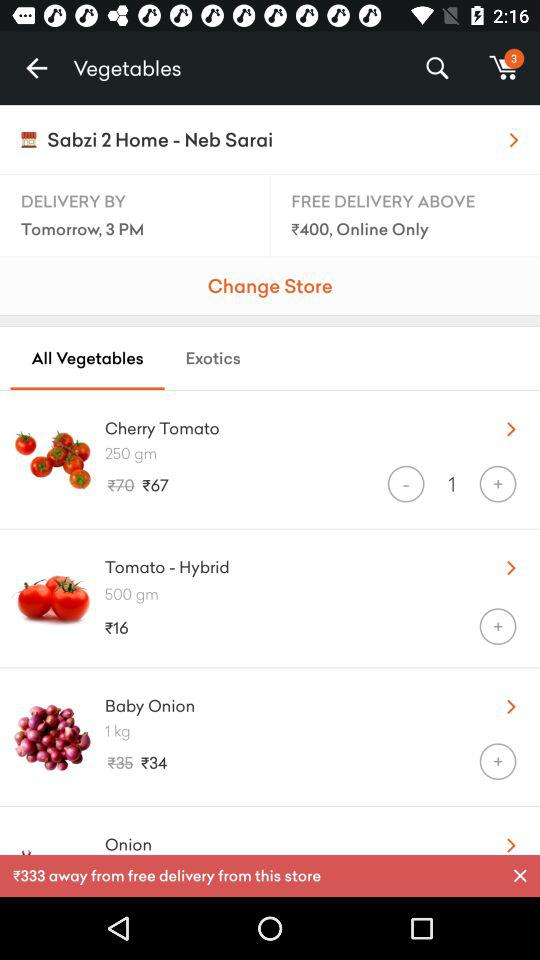What is the name of the vegetable whose price is 34 rupees? The name of the vegetable is "Baby Onion". 